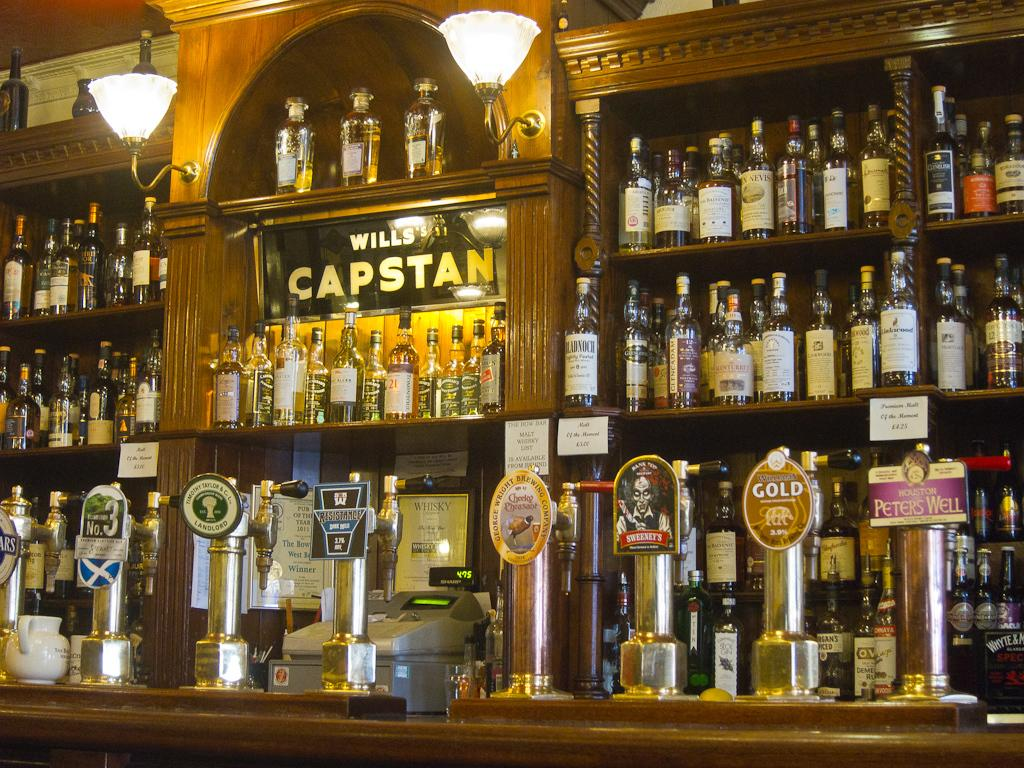<image>
Offer a succinct explanation of the picture presented. A bar with lots of alcoholic offerings and a sign that says Wills's Capstan. 